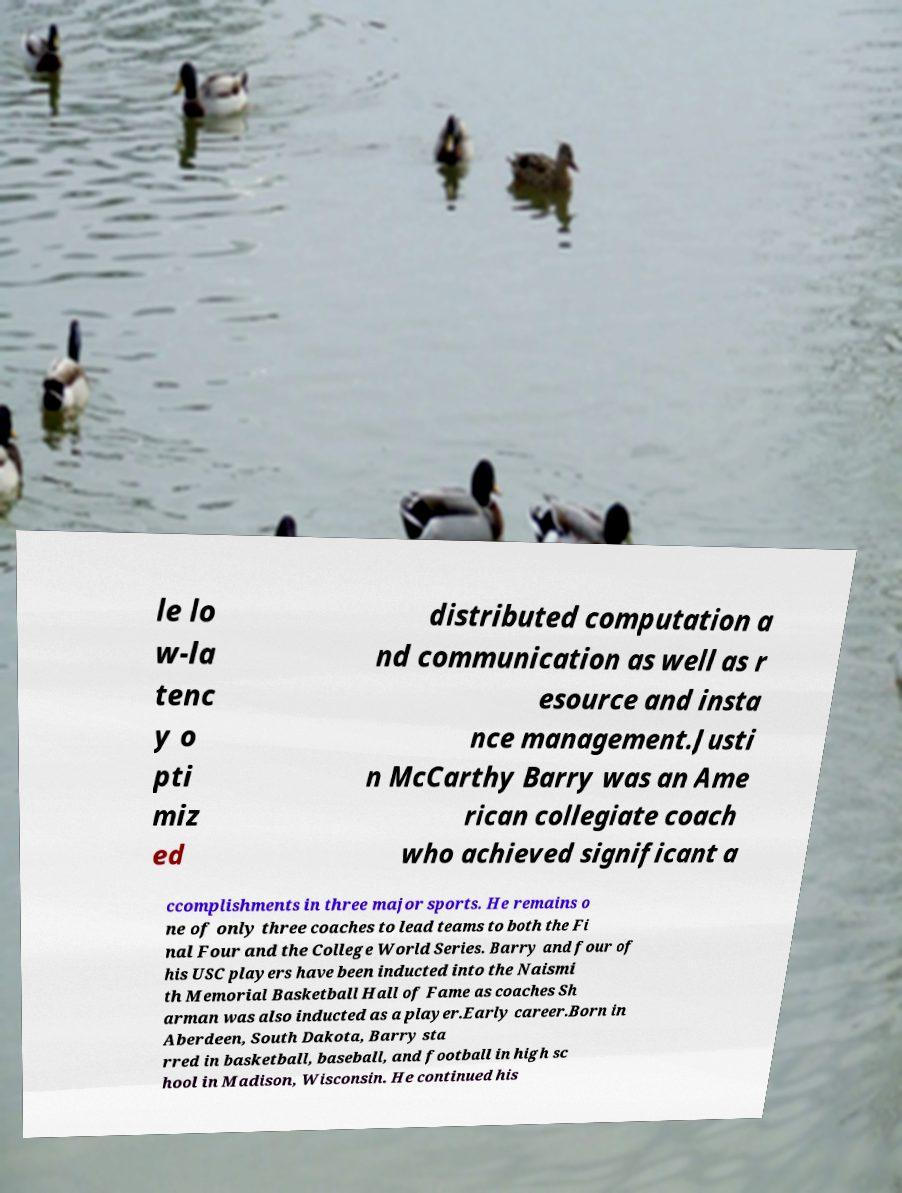For documentation purposes, I need the text within this image transcribed. Could you provide that? le lo w-la tenc y o pti miz ed distributed computation a nd communication as well as r esource and insta nce management.Justi n McCarthy Barry was an Ame rican collegiate coach who achieved significant a ccomplishments in three major sports. He remains o ne of only three coaches to lead teams to both the Fi nal Four and the College World Series. Barry and four of his USC players have been inducted into the Naismi th Memorial Basketball Hall of Fame as coaches Sh arman was also inducted as a player.Early career.Born in Aberdeen, South Dakota, Barry sta rred in basketball, baseball, and football in high sc hool in Madison, Wisconsin. He continued his 